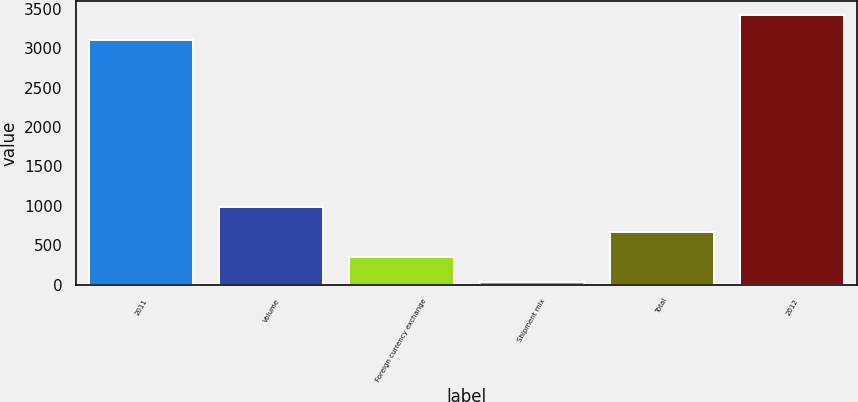Convert chart. <chart><loc_0><loc_0><loc_500><loc_500><bar_chart><fcel>2011<fcel>Volume<fcel>Foreign currency exchange<fcel>Shipment mix<fcel>Total<fcel>2012<nl><fcel>3106<fcel>987.2<fcel>348.4<fcel>29<fcel>667.8<fcel>3425.4<nl></chart> 